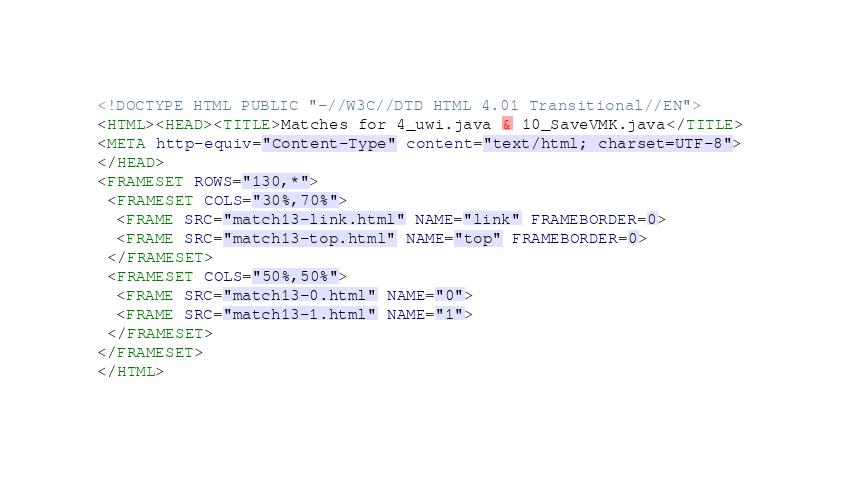<code> <loc_0><loc_0><loc_500><loc_500><_HTML_><!DOCTYPE HTML PUBLIC "-//W3C//DTD HTML 4.01 Transitional//EN">
<HTML><HEAD><TITLE>Matches for 4_uwi.java & 10_SaveVMK.java</TITLE>
<META http-equiv="Content-Type" content="text/html; charset=UTF-8">
</HEAD>
<FRAMESET ROWS="130,*">
 <FRAMESET COLS="30%,70%">
  <FRAME SRC="match13-link.html" NAME="link" FRAMEBORDER=0>
  <FRAME SRC="match13-top.html" NAME="top" FRAMEBORDER=0>
 </FRAMESET>
 <FRAMESET COLS="50%,50%">
  <FRAME SRC="match13-0.html" NAME="0">
  <FRAME SRC="match13-1.html" NAME="1">
 </FRAMESET>
</FRAMESET>
</HTML>
</code> 